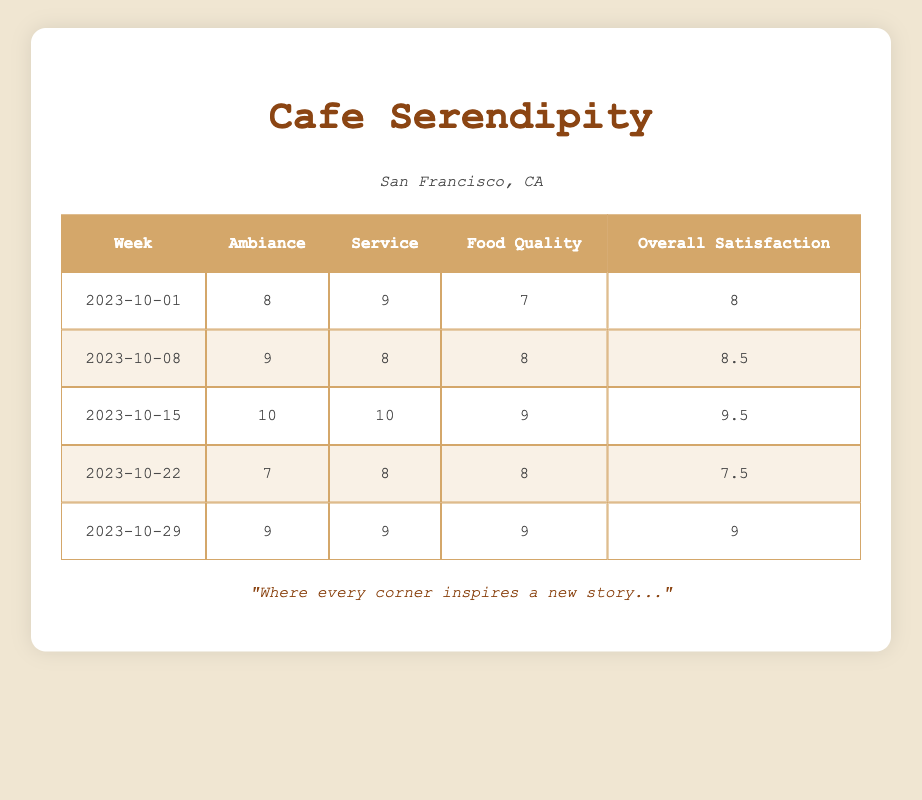What was the ambiance score for the week of October 15, 2023? In the table, the ambiance score for the week of October 15, 2023, is directly listed as 10.
Answer: 10 What is the overall satisfaction score for the week of October 22, 2023? The overall satisfaction score for that week is explicitly shown in the table, which is 7.5.
Answer: 7.5 Did the food quality score ever reach 10 during the weeks listed? By examining the food quality scores listed in the table, the highest value is 9 for the week of October 15, 2023, so the answer is no.
Answer: No Which week had the highest service score? The maximum service score is 10, which occurred during the week of October 15, 2023, based on the scores shown in the table.
Answer: October 15, 2023 What is the average ambiance score across all weeks? To find the average ambiance score, sum the ambiance scores (8 + 9 + 10 + 7 + 9 = 43) and divide by the number of weeks (5). This results in an average of 8.6.
Answer: 8.6 Was the overall satisfaction score higher than the food quality score for the week of October 08, 2023? For that week, the overall satisfaction score is 8.5 and the food quality score is 8. Since 8.5 is greater than 8, the answer is yes.
Answer: Yes What is the difference between the highest and lowest ambiance scores recorded? The highest ambiance score is 10 (week of October 15) and the lowest is 7 (week of October 22). The difference is 10 - 7 = 3.
Answer: 3 For which week was the food quality score equal to the overall satisfaction score? Looking through the table, the food quality score was equal to the overall satisfaction score for the week of October 29, where both were 9.
Answer: October 29, 2023 Which week displayed a drop in ambiance score compared to the previous week? Comparing the ambiance scores, October 22 (7) is lower than the previous week October 15 (10), indicating a drop in that week.
Answer: October 22, 2023 